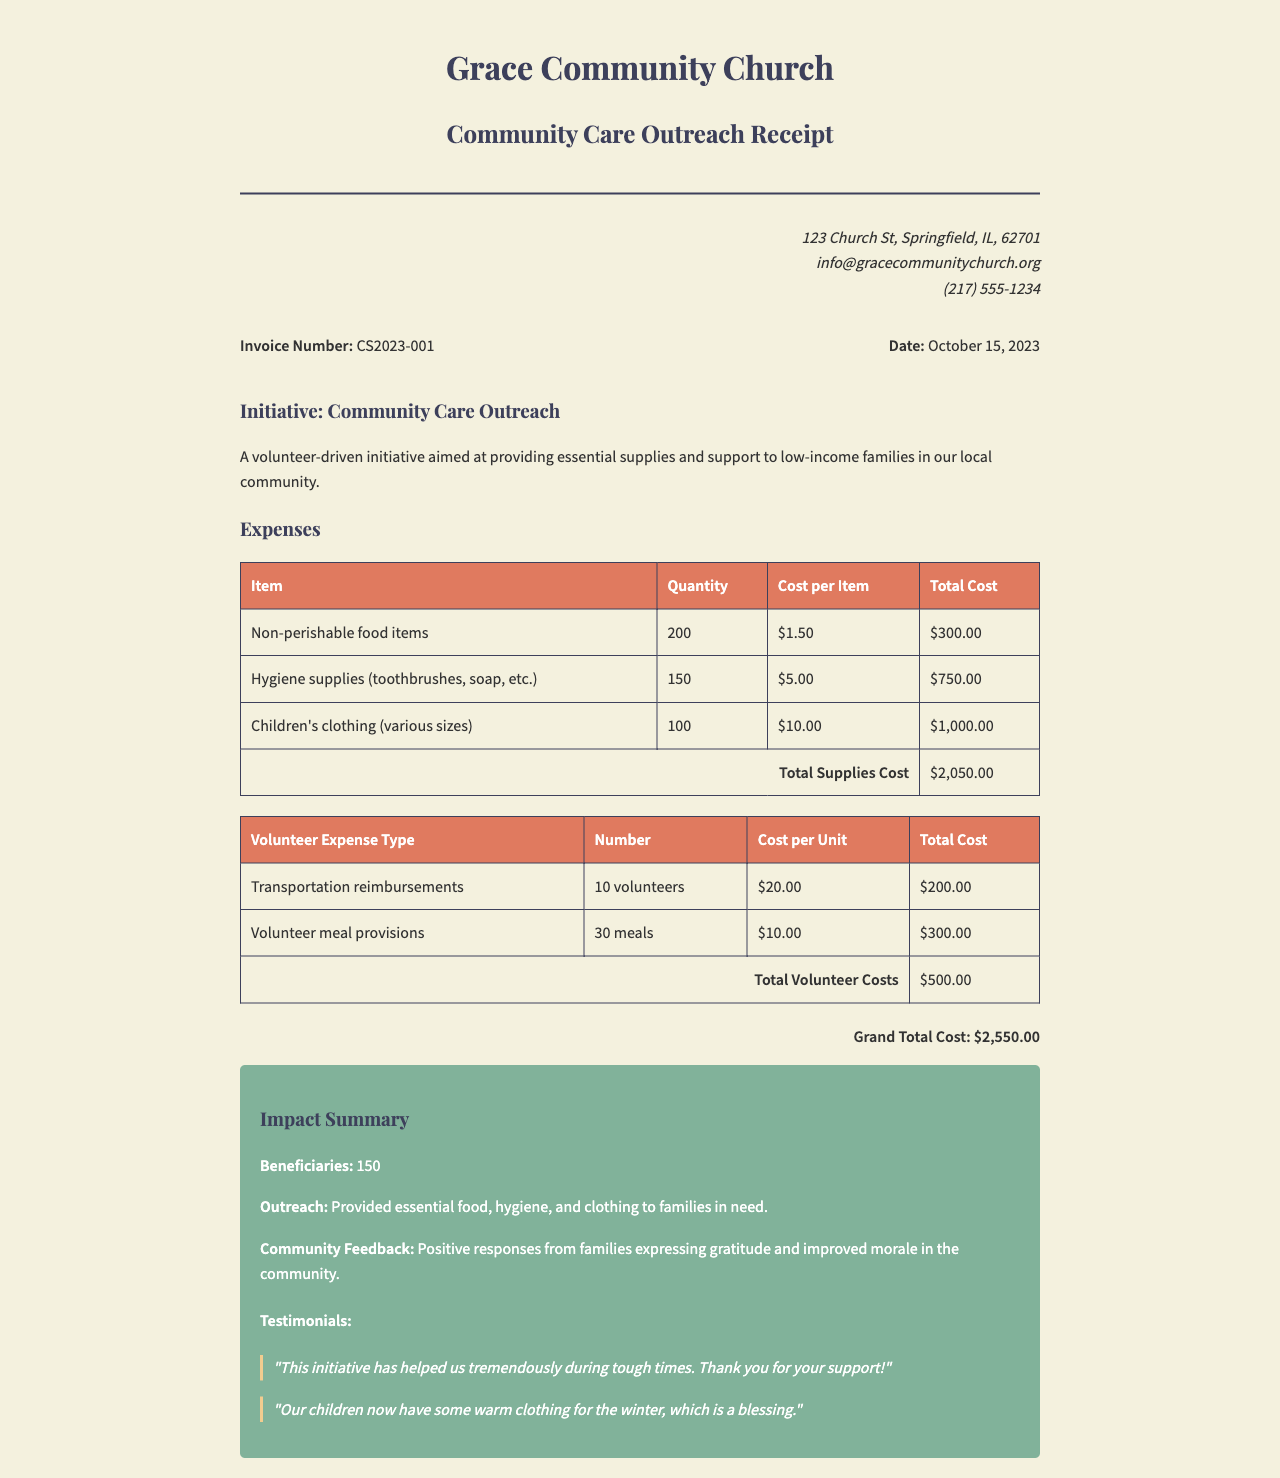What is the invoice number? The invoice number is found in the invoice details section of the document.
Answer: CS2023-001 What is the total cost for supplies? The total cost for supplies is detailed in the expenses table.
Answer: $2,050.00 How many hygiene supplies were purchased? The quantity of hygiene supplies is listed in the supplies table.
Answer: 150 What is the date of the invoice? The date of the invoice is specified in the invoice details section.
Answer: October 15, 2023 What was the total cost for volunteer expenses? The total cost for volunteer expenses is provided in the expenses table.
Answer: $500.00 What was the grand total cost? The grand total cost is mentioned at the bottom of the invoice as the final amount.
Answer: $2,550.00 How many beneficiaries were impacted by the initiative? The number of beneficiaries is stated in the impact summary section.
Answer: 150 What type of support was provided to families in need? The specific types of support can be found in the outreach description.
Answer: Food, hygiene, and clothing What feedback was received from families? Feedback is summarized in the community feedback section of the impact.
Answer: Positive responses How many volunteers received transportation reimbursements? The number of volunteers is specified in the volunteer expense table.
Answer: 10 volunteers 